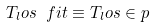Convert formula to latex. <formula><loc_0><loc_0><loc_500><loc_500>T _ { l } o s \ f i t \equiv T _ { l } o s \in p</formula> 